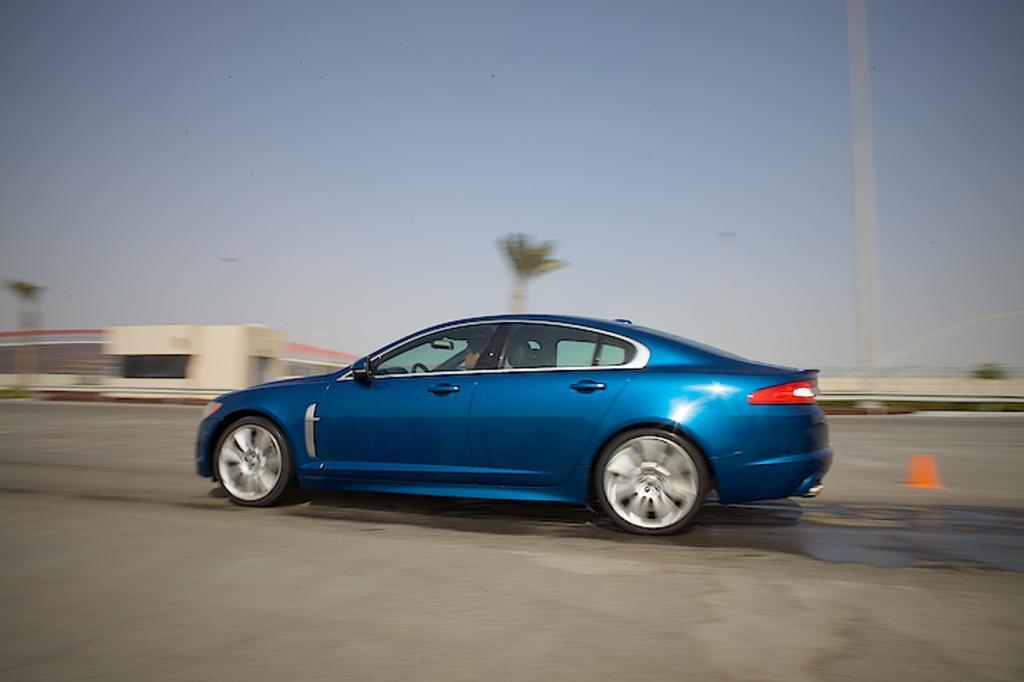Could you give a brief overview of what you see in this image? In this image I can see the road, a car which is blue in color, a person in the car, a traffic pole, few buildings and few trees. In the background I can see the sky. 